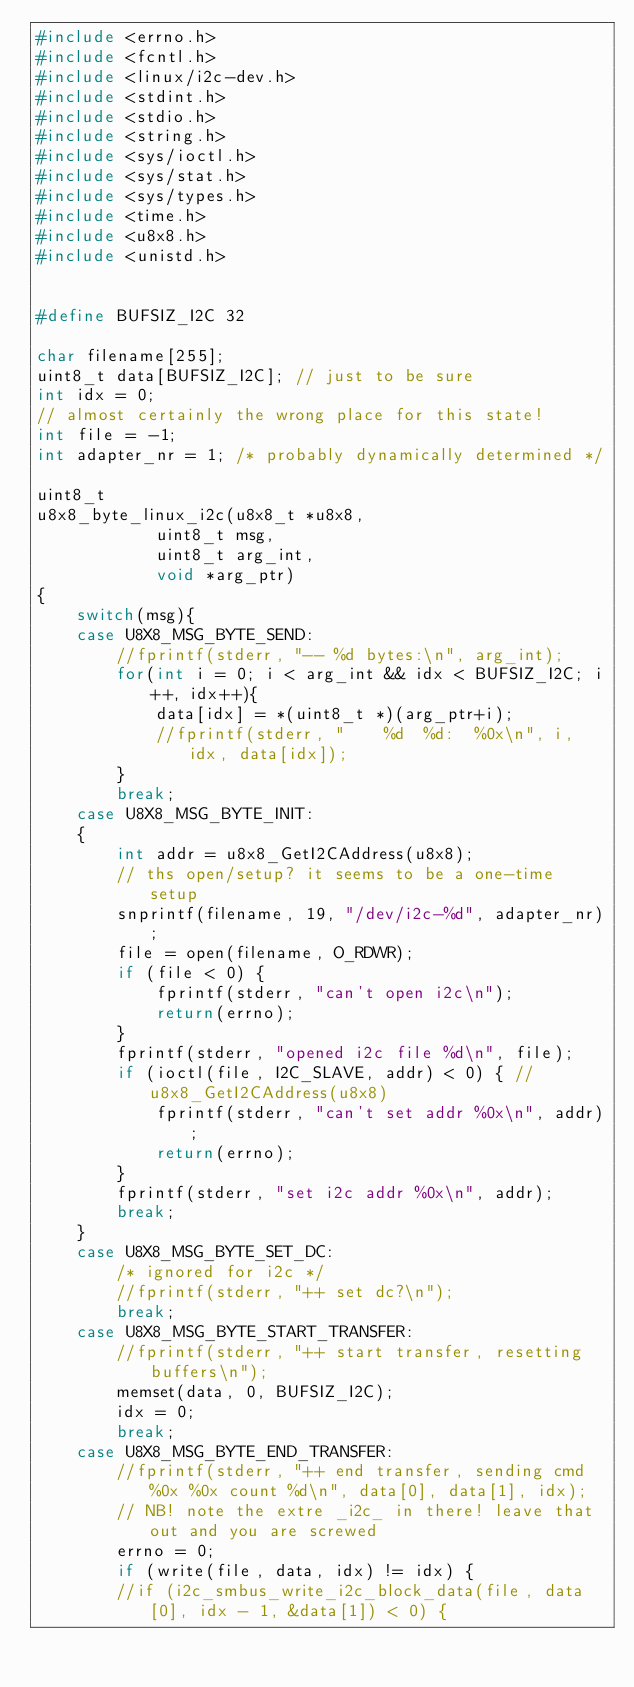<code> <loc_0><loc_0><loc_500><loc_500><_C_>#include <errno.h>
#include <fcntl.h>
#include <linux/i2c-dev.h>
#include <stdint.h>
#include <stdio.h>
#include <string.h>
#include <sys/ioctl.h>
#include <sys/stat.h>
#include <sys/types.h>
#include <time.h>
#include <u8x8.h>
#include <unistd.h>


#define BUFSIZ_I2C 32

char filename[255];
uint8_t data[BUFSIZ_I2C]; // just to be sure
int idx = 0;
// almost certainly the wrong place for this state!
int file = -1;
int adapter_nr = 1; /* probably dynamically determined */

uint8_t
u8x8_byte_linux_i2c(u8x8_t *u8x8,
		    uint8_t msg,
		    uint8_t arg_int,
		    void *arg_ptr)
{
	switch(msg){
	case U8X8_MSG_BYTE_SEND:
		//fprintf(stderr, "-- %d bytes:\n", arg_int);
		for(int i = 0; i < arg_int && idx < BUFSIZ_I2C; i++, idx++){
			data[idx] = *(uint8_t *)(arg_ptr+i);
			//fprintf(stderr, "    %d  %d:  %0x\n", i, idx, data[idx]);
		}
		break;
	case U8X8_MSG_BYTE_INIT:
	{
		int addr = u8x8_GetI2CAddress(u8x8);
		// ths open/setup? it seems to be a one-time setup
		snprintf(filename, 19, "/dev/i2c-%d", adapter_nr);
		file = open(filename, O_RDWR);
		if (file < 0) {
			fprintf(stderr, "can't open i2c\n");
			return(errno); 
		}
		fprintf(stderr, "opened i2c file %d\n", file);
		if (ioctl(file, I2C_SLAVE, addr) < 0) { // u8x8_GetI2CAddress(u8x8)
			fprintf(stderr, "can't set addr %0x\n", addr);
			return(errno);
		}
		fprintf(stderr, "set i2c addr %0x\n", addr);
		break;
	}
	case U8X8_MSG_BYTE_SET_DC:
		/* ignored for i2c */
		//fprintf(stderr, "++ set dc?\n");
		break;
	case U8X8_MSG_BYTE_START_TRANSFER:
		//fprintf(stderr, "++ start transfer, resetting buffers\n");
		memset(data, 0, BUFSIZ_I2C);
		idx = 0;
		break;
	case U8X8_MSG_BYTE_END_TRANSFER:
		//fprintf(stderr, "++ end transfer, sending cmd %0x %0x count %d\n", data[0], data[1], idx);
		// NB! note the extre _i2c_ in there! leave that out and you are screwed
		errno = 0;
		if (write(file, data, idx) != idx) {
		//if (i2c_smbus_write_i2c_block_data(file, data[0], idx - 1, &data[1]) < 0) {</code> 